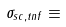Convert formula to latex. <formula><loc_0><loc_0><loc_500><loc_500>\sigma _ { s c , t n f } \equiv</formula> 